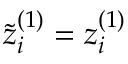Convert formula to latex. <formula><loc_0><loc_0><loc_500><loc_500>\tilde { z } _ { i } ^ { ( 1 ) } = z _ { i } ^ { ( 1 ) }</formula> 